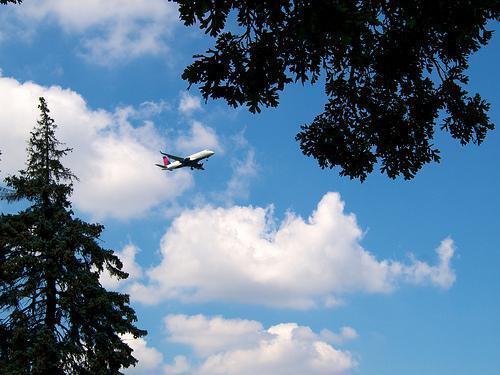How many planes are there?
Give a very brief answer. 1. 